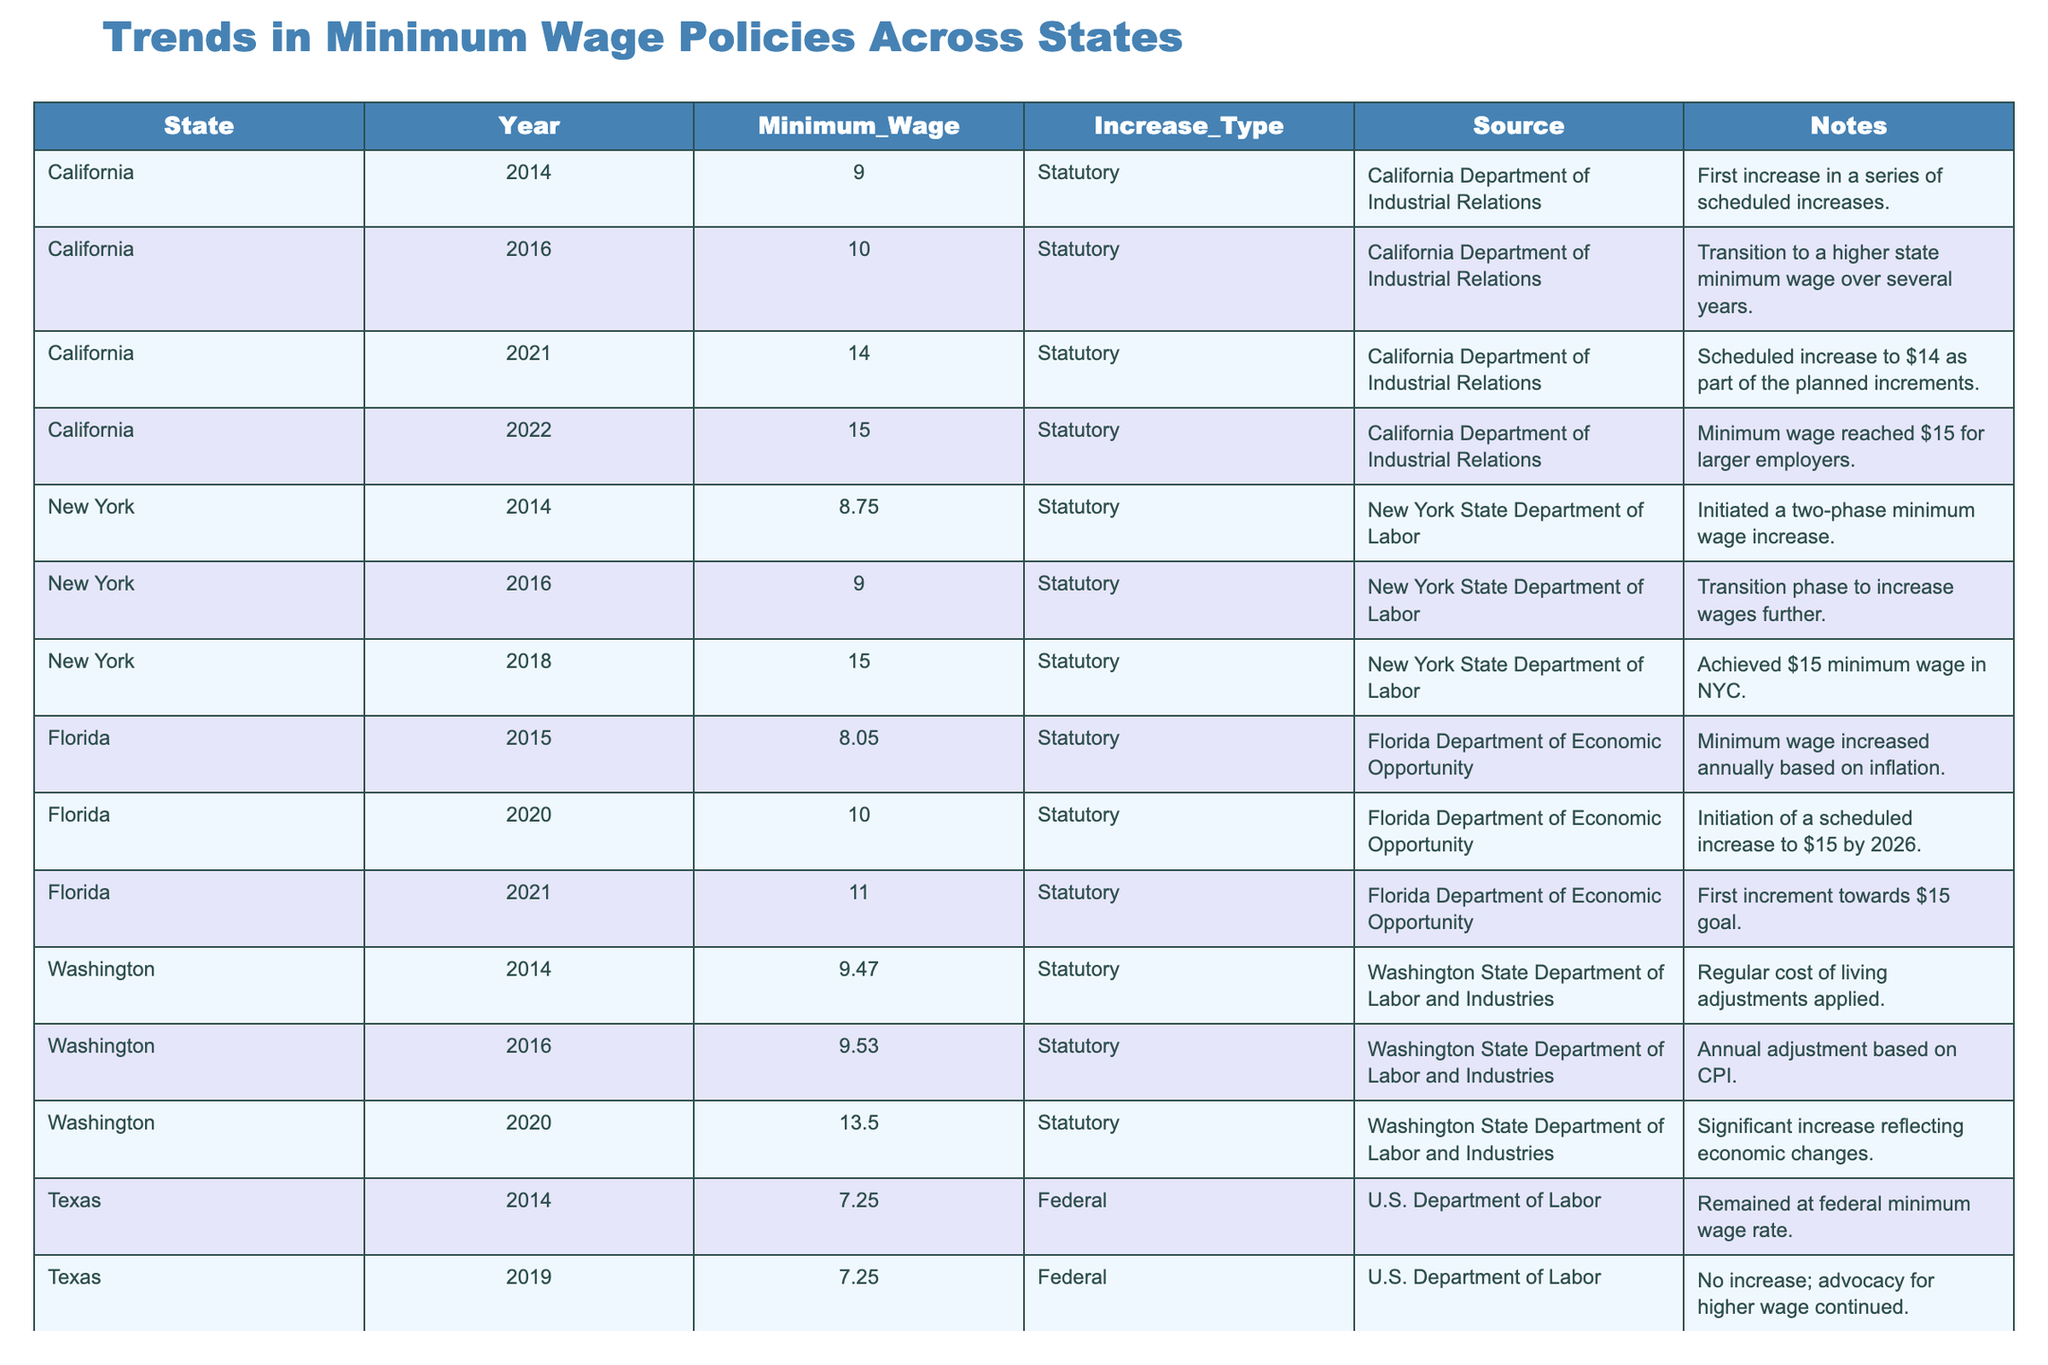What was the minimum wage in California in 2022? Referring to the table, California's minimum wage in 2022 is listed as $15.00.
Answer: $15.00 What is the increase type for the minimum wage in Florida in 2021? The table shows that the increase type for Florida in 2021 is "Statutory."
Answer: Statutory How much did the minimum wage in New York increase from 2014 to 2018? The minimum wage in New York was $8.75 in 2014 and increased to $15.00 in 2018. The increase is calculated as $15.00 - $8.75 = $6.25.
Answer: $6.25 Did Texas raise its minimum wage between 2014 and 2019? The table indicates that Texas maintained a minimum wage of $7.25 during both years, so there was no increase.
Answer: No Which state had the highest minimum wage in 2021? By looking at the table, California had a minimum wage of $14.00 in 2021, which is higher than any other state listed.
Answer: California What was the average minimum wage across the listed states in 2020? The minimum wages for the states in 2020 were: California ($14.00), New York ($15.00), Florida ($10.00), Washington ($13.50), Texas ($7.25), Illinois ($10.00), Colorado ($12.00), and Massachusetts ($13.50). Summing these gives $14.00 + $15.00 + $10.00 + $13.50 + $7.25 + $10.00 + $12.00 + $13.50 = $105.25. There are 8 states, so the average is $105.25 / 8 = $13.16.
Answer: $13.16 What trend can be observed in California's minimum wage policy from 2014 to 2022? The table shows a progressive increase in California's minimum wage from $9.00 in 2014 to $15.00 in 2022, indicating a phased approach to reaching a higher minimum wage.
Answer: Progressive increase Is there a state that reached a minimum wage of $15 before 2021? The data shows that New York achieved a minimum wage of $15.00 in 2018, which is before 2021.
Answer: Yes How does Florida's minimum wage in 2021 compare to that in 2015? In 2015, Florida's minimum wage was $8.05 and in 2021 it rose to $11.00. The difference is $11.00 - $8.05 = $2.95.
Answer: $2.95 Which state had the lowest minimum wage in 2014? According to the table, Texas had the lowest minimum wage of $7.25 in 2014.
Answer: Texas What is the overall trend in minimum wage increases among states from 2014 to 2022? By reviewing the table, it is apparent that most states have either initiated or continued to raise their minimum wages systematically over this period, indicative of a national trend toward higher wages.
Answer: Trend towards higher wages 